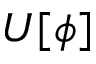<formula> <loc_0><loc_0><loc_500><loc_500>U [ \phi ]</formula> 